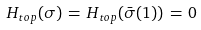<formula> <loc_0><loc_0><loc_500><loc_500>H _ { t o p } ( \sigma ) \, = \, H _ { t o p } ( \bar { \sigma } ( 1 ) ) \, = \, 0</formula> 